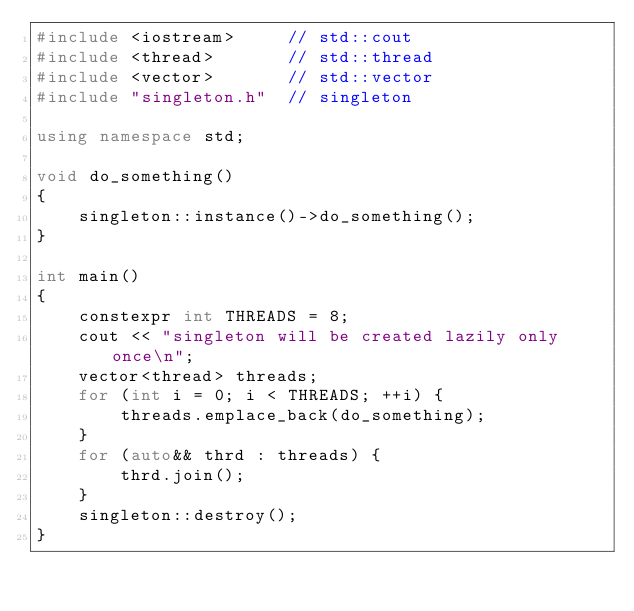Convert code to text. <code><loc_0><loc_0><loc_500><loc_500><_C++_>#include <iostream>     // std::cout
#include <thread>       // std::thread
#include <vector>       // std::vector
#include "singleton.h"  // singleton

using namespace std;

void do_something()
{
    singleton::instance()->do_something();
}

int main()
{
    constexpr int THREADS = 8;
    cout << "singleton will be created lazily only once\n";
    vector<thread> threads;
    for (int i = 0; i < THREADS; ++i) {
        threads.emplace_back(do_something);
    }
    for (auto&& thrd : threads) {
        thrd.join();
    }
    singleton::destroy();
}
</code> 